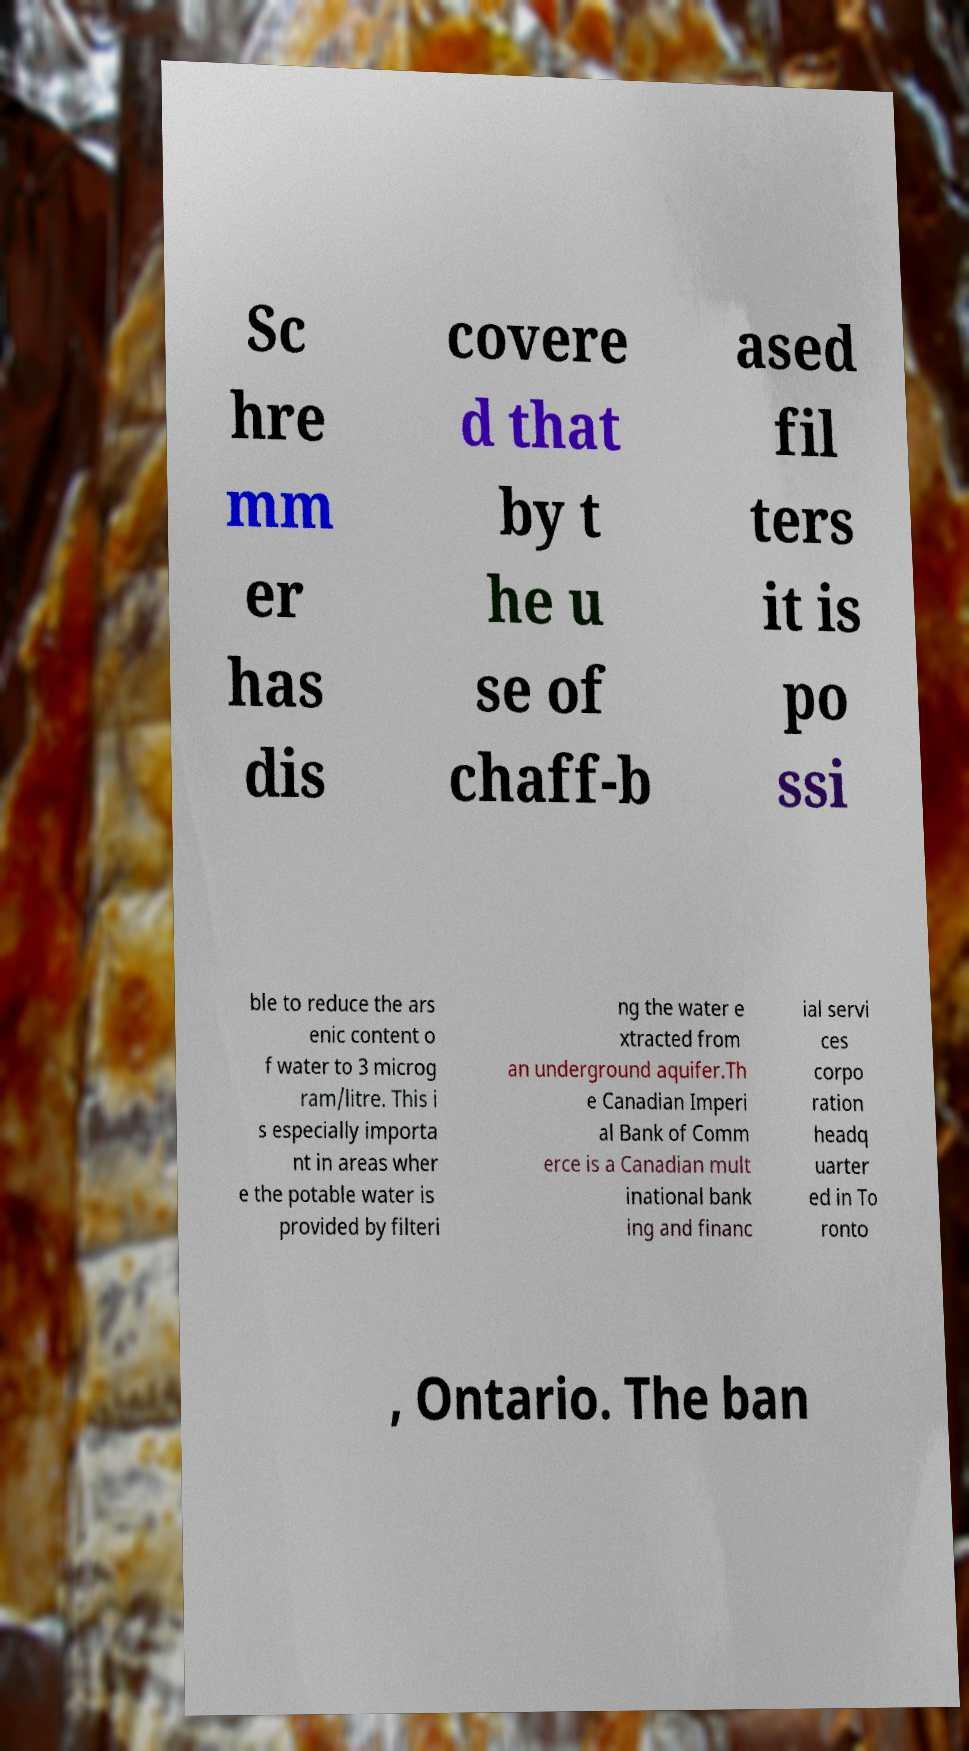Could you assist in decoding the text presented in this image and type it out clearly? Sc hre mm er has dis covere d that by t he u se of chaff-b ased fil ters it is po ssi ble to reduce the ars enic content o f water to 3 microg ram/litre. This i s especially importa nt in areas wher e the potable water is provided by filteri ng the water e xtracted from an underground aquifer.Th e Canadian Imperi al Bank of Comm erce is a Canadian mult inational bank ing and financ ial servi ces corpo ration headq uarter ed in To ronto , Ontario. The ban 